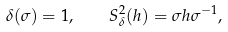<formula> <loc_0><loc_0><loc_500><loc_500>\delta ( \sigma ) = 1 , \quad S _ { \delta } ^ { 2 } ( h ) = \sigma h \sigma ^ { - 1 } ,</formula> 